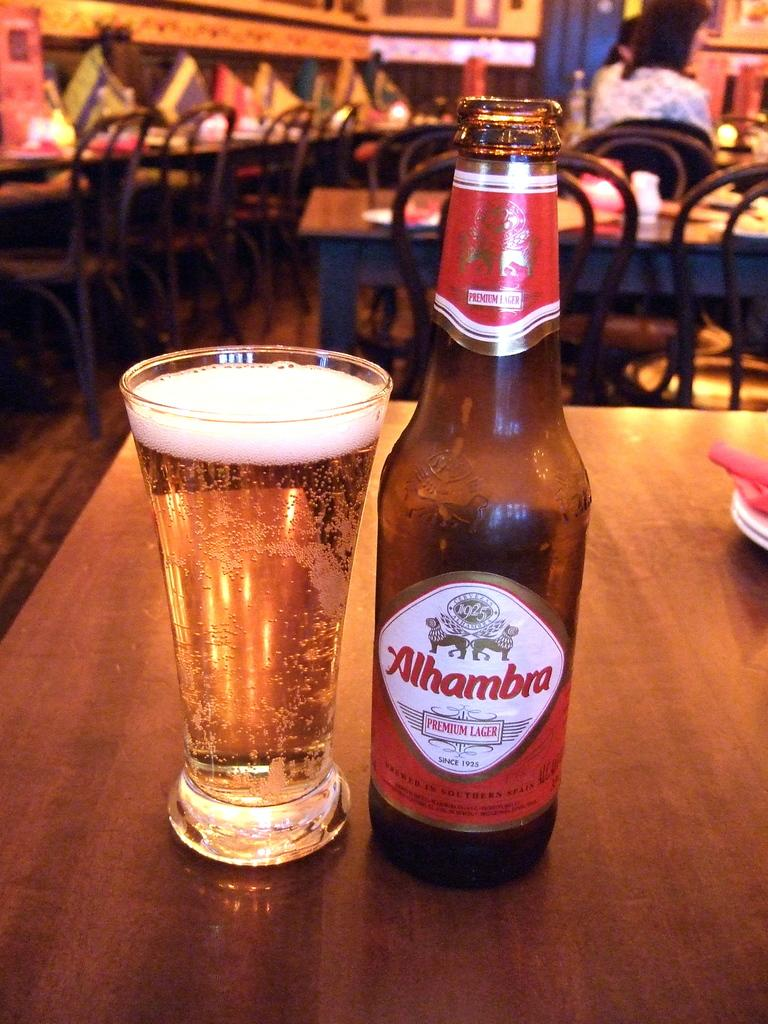What type of furniture is present in the image? There are tables and chairs in the image. What objects can be seen on the table? There is a bottle and a glass on the table. What type of hydrant is visible in the image? There is no hydrant present in the image. What material is the ink made of in the image? There is no ink present in the image. 